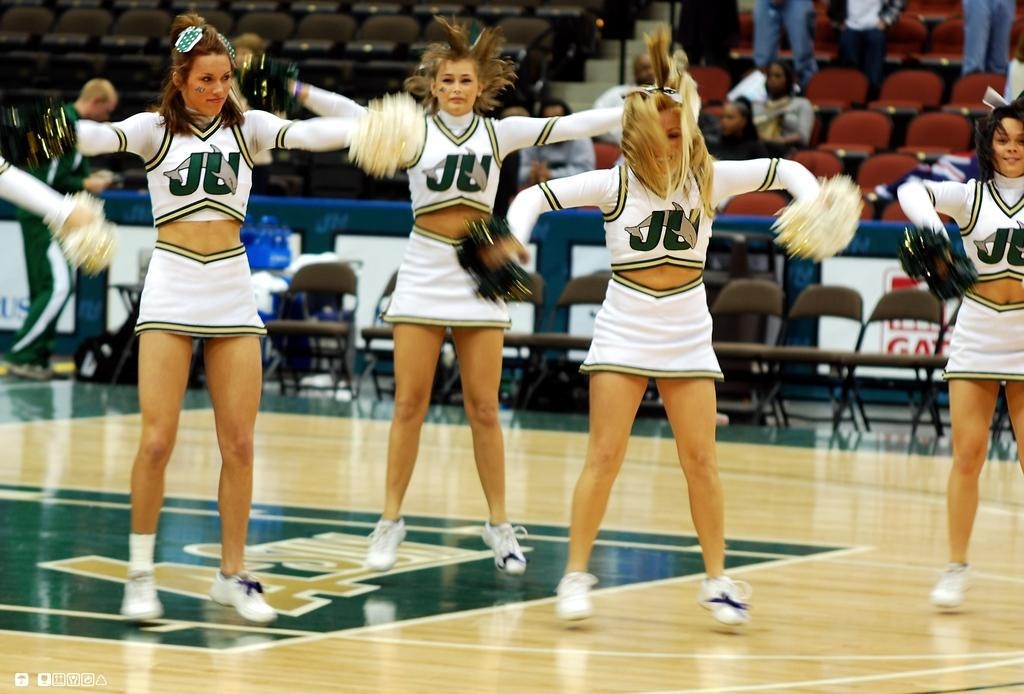<image>
Give a short and clear explanation of the subsequent image. Four cheerleaders  wearing white uniforms with the letters JU on the front of their shirts. 